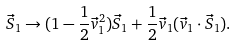Convert formula to latex. <formula><loc_0><loc_0><loc_500><loc_500>\vec { S } _ { 1 } \to ( 1 - \frac { 1 } { 2 } \vec { v } _ { 1 } ^ { 2 } ) \vec { S } _ { 1 } + \frac { 1 } { 2 } \vec { v } _ { 1 } ( \vec { v } _ { 1 } \cdot \vec { S } _ { 1 } ) .</formula> 